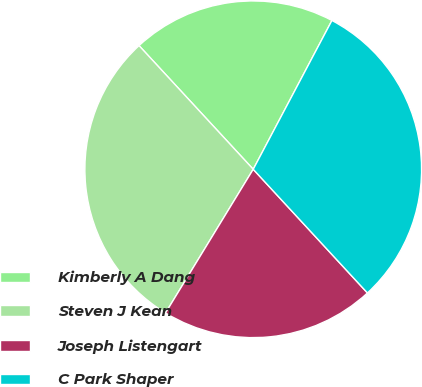Convert chart. <chart><loc_0><loc_0><loc_500><loc_500><pie_chart><fcel>Kimberly A Dang<fcel>Steven J Kean<fcel>Joseph Listengart<fcel>C Park Shaper<nl><fcel>19.61%<fcel>29.41%<fcel>20.59%<fcel>30.39%<nl></chart> 